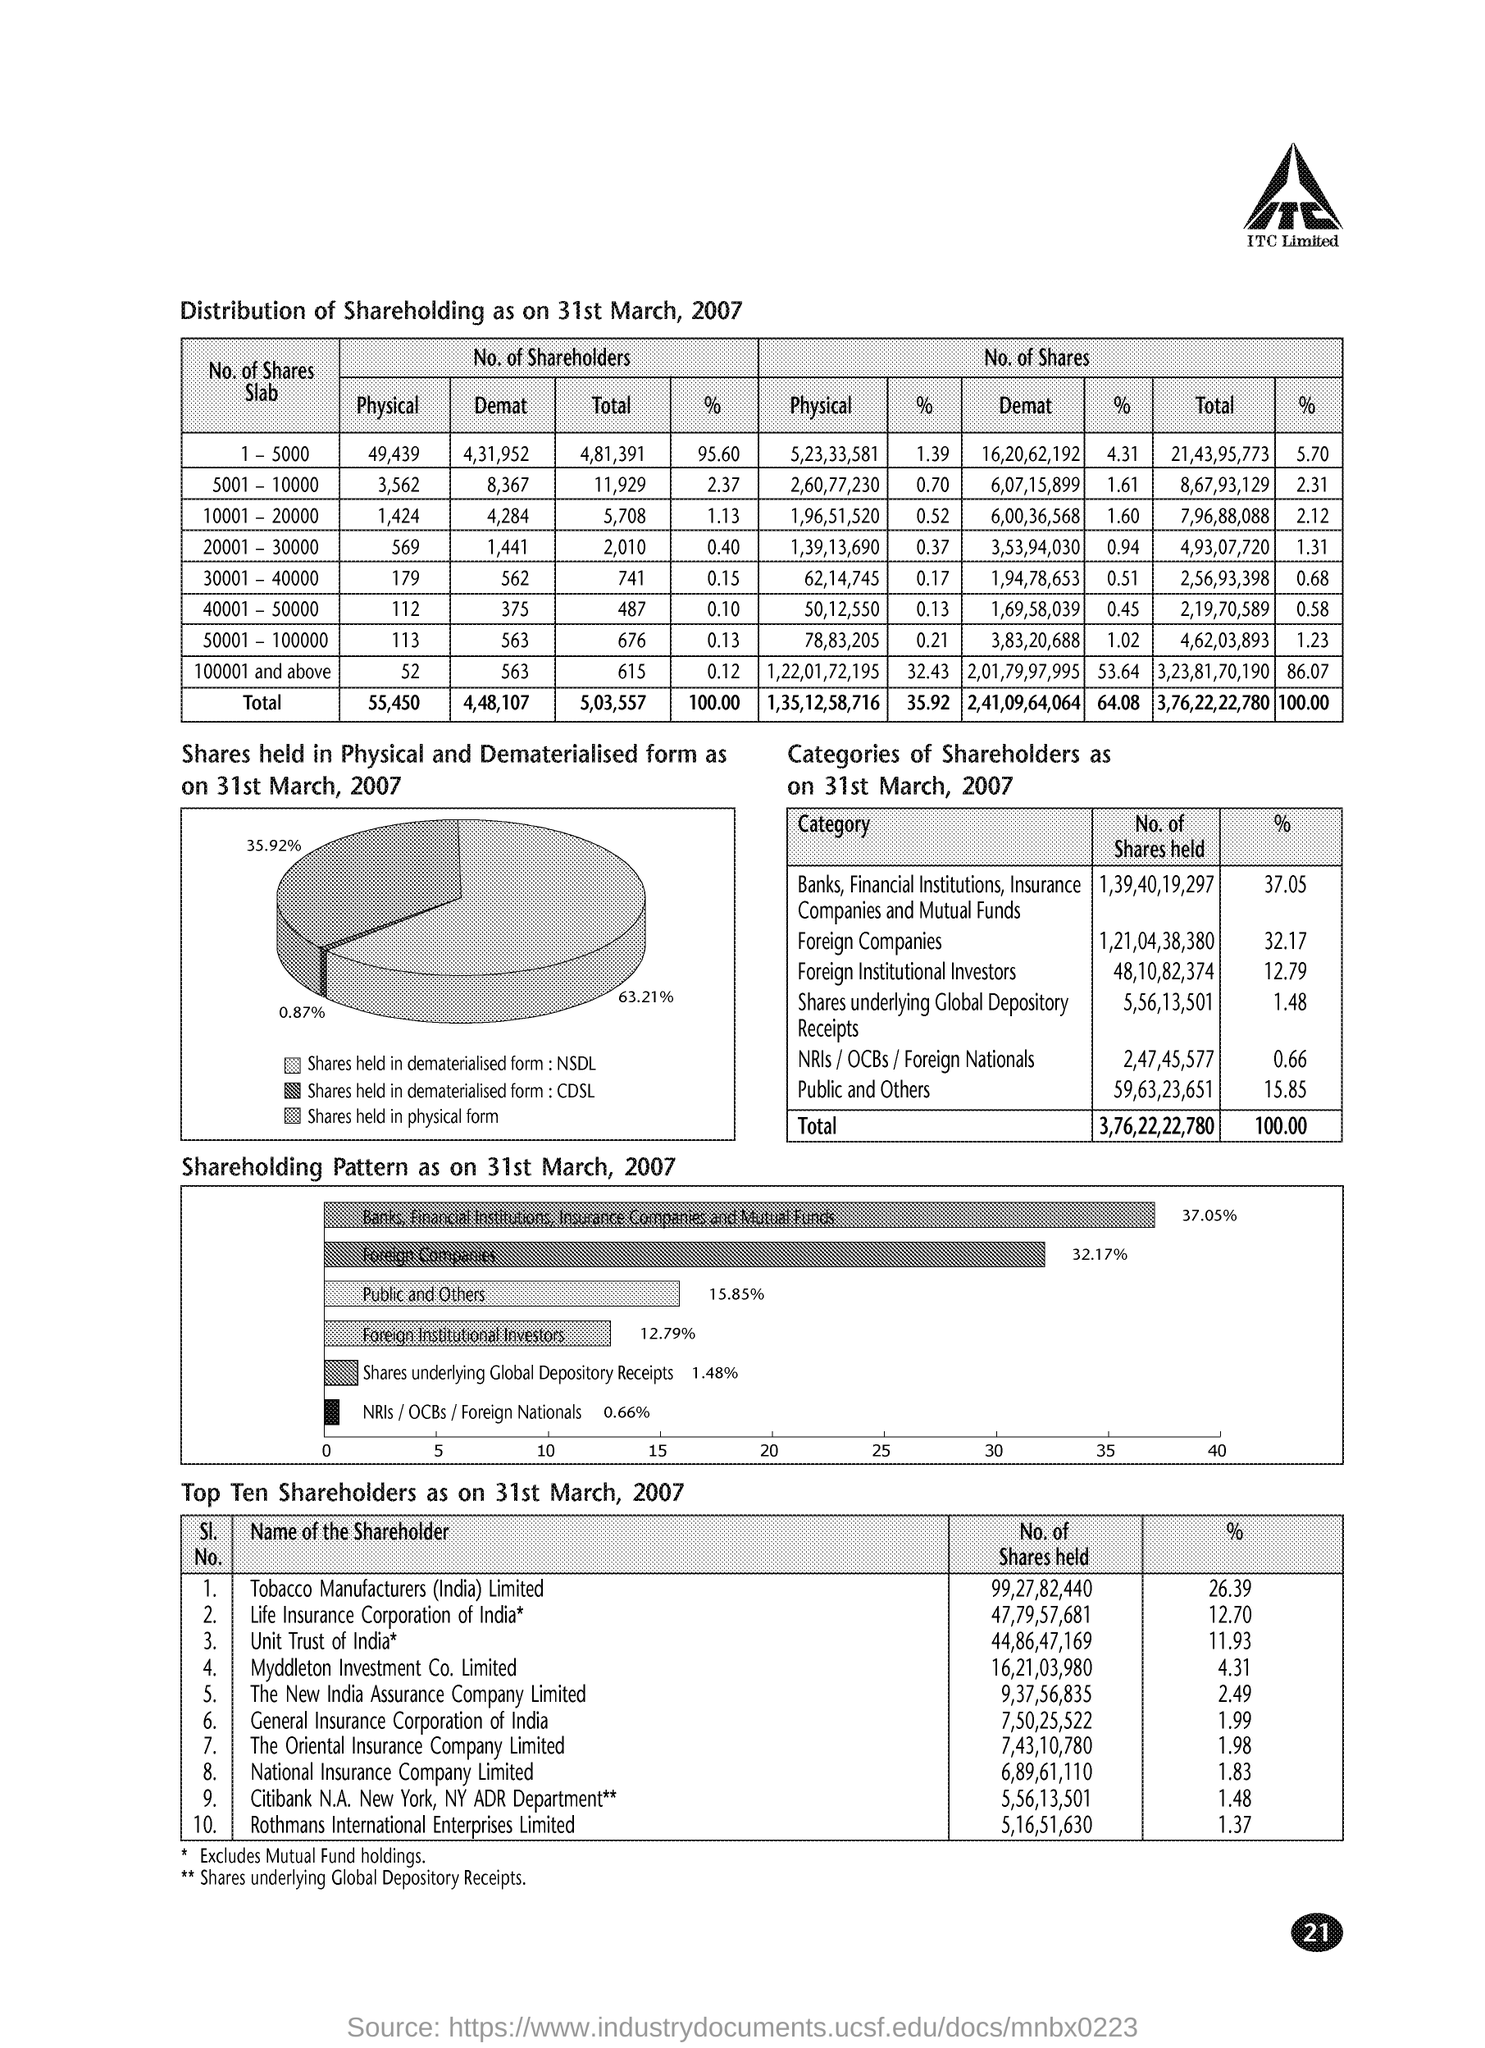What percent of share is held by Foreign Companies as on 31st March, 2007?
 32.17 